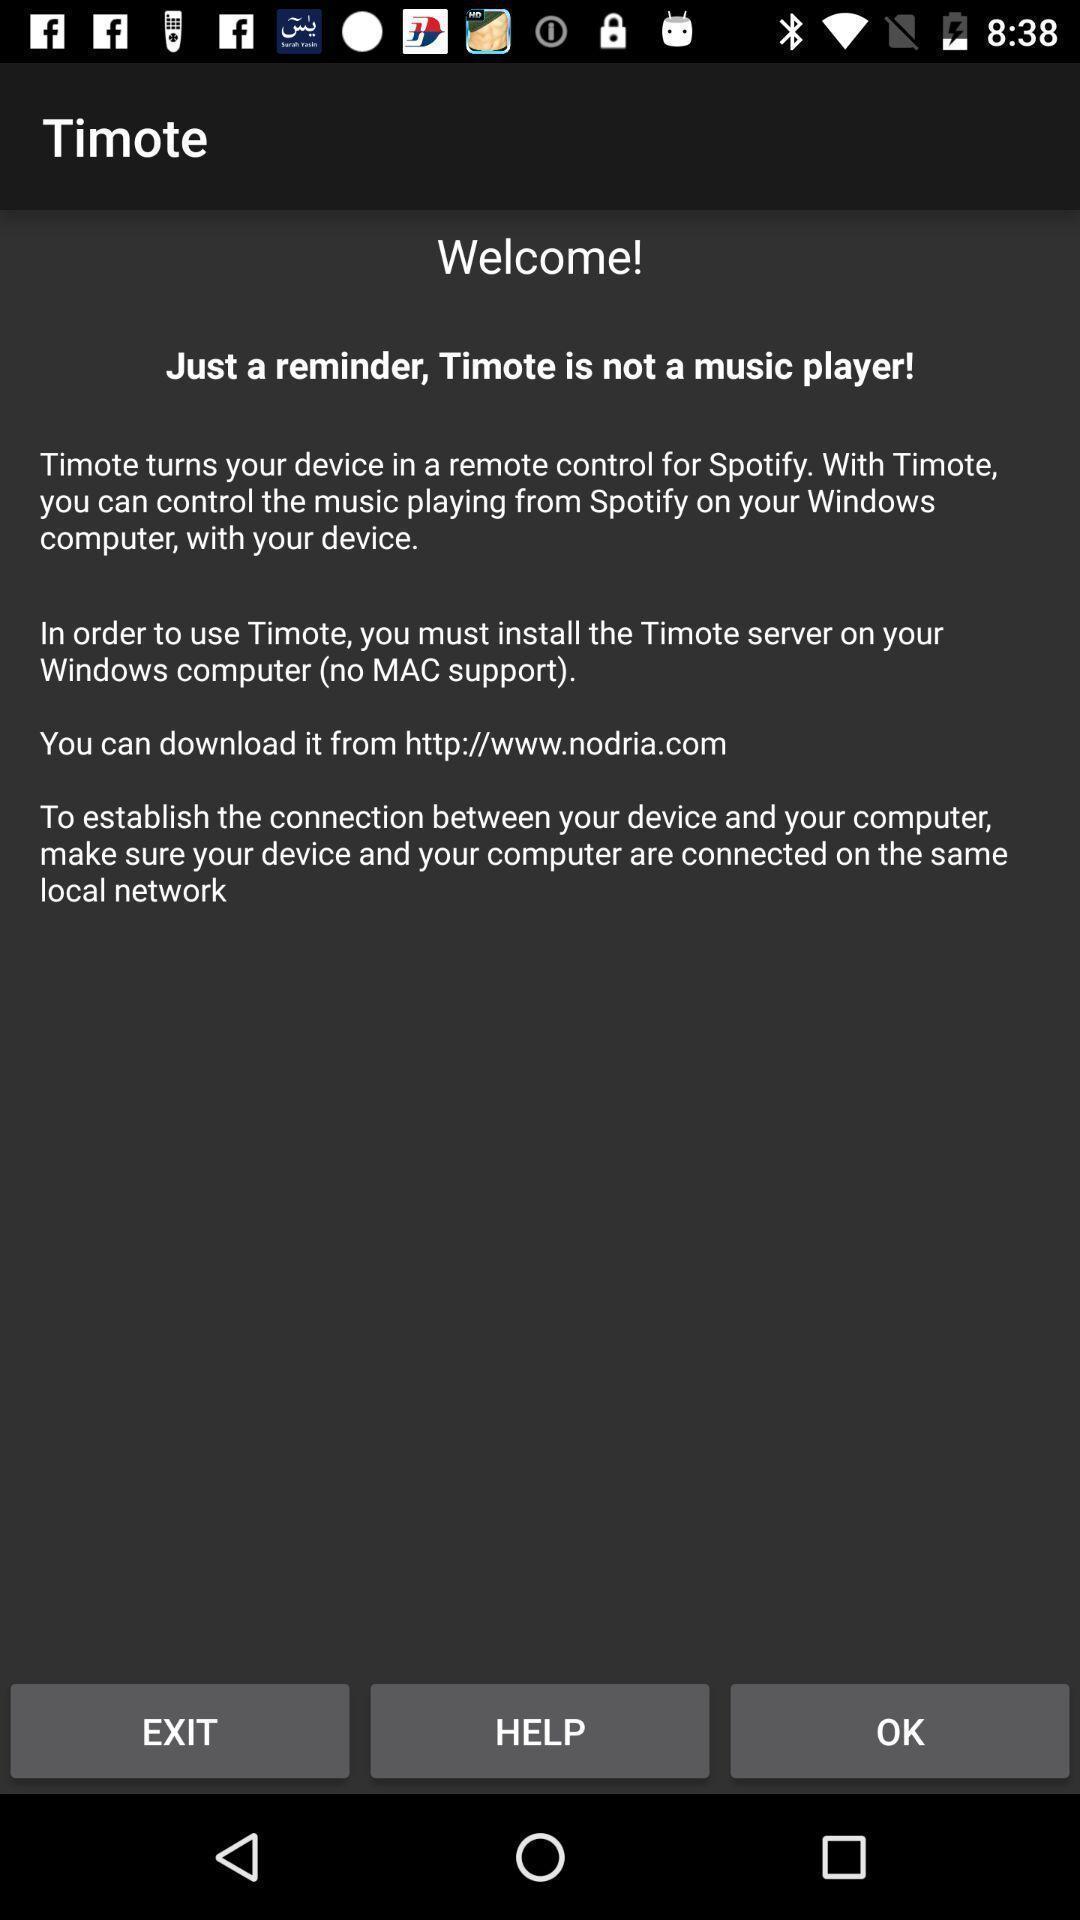Summarize the main components in this picture. Welcome page for a remote controlling app. 